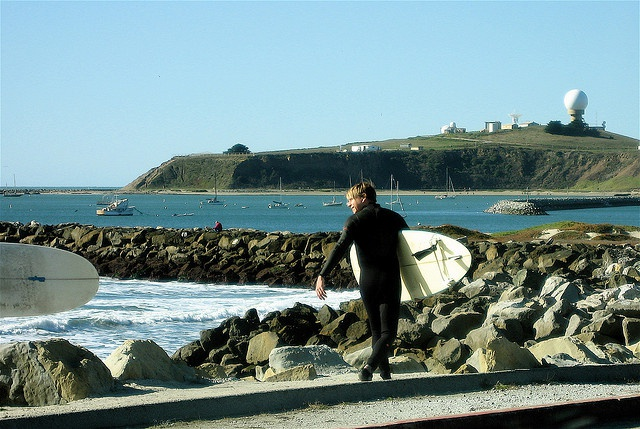Describe the objects in this image and their specific colors. I can see people in lightblue, black, gray, ivory, and darkgreen tones, surfboard in lightblue and gray tones, surfboard in lightblue, ivory, gray, black, and darkgreen tones, boat in lightblue, blue, black, gray, and teal tones, and boat in lightblue, teal, gray, and black tones in this image. 